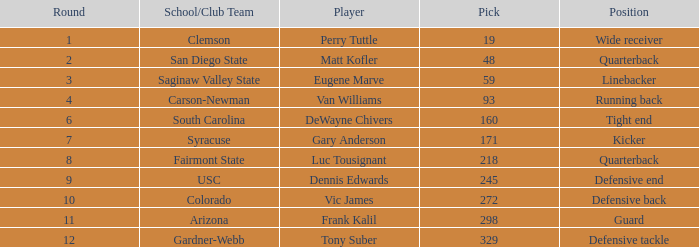Who plays linebacker? Eugene Marve. 